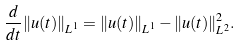Convert formula to latex. <formula><loc_0><loc_0><loc_500><loc_500>\frac { d } { d t } \| u ( t ) \| _ { L ^ { 1 } } = \| u ( t ) \| _ { L ^ { 1 } } - \| u ( t ) \| _ { L ^ { 2 } } ^ { 2 } .</formula> 